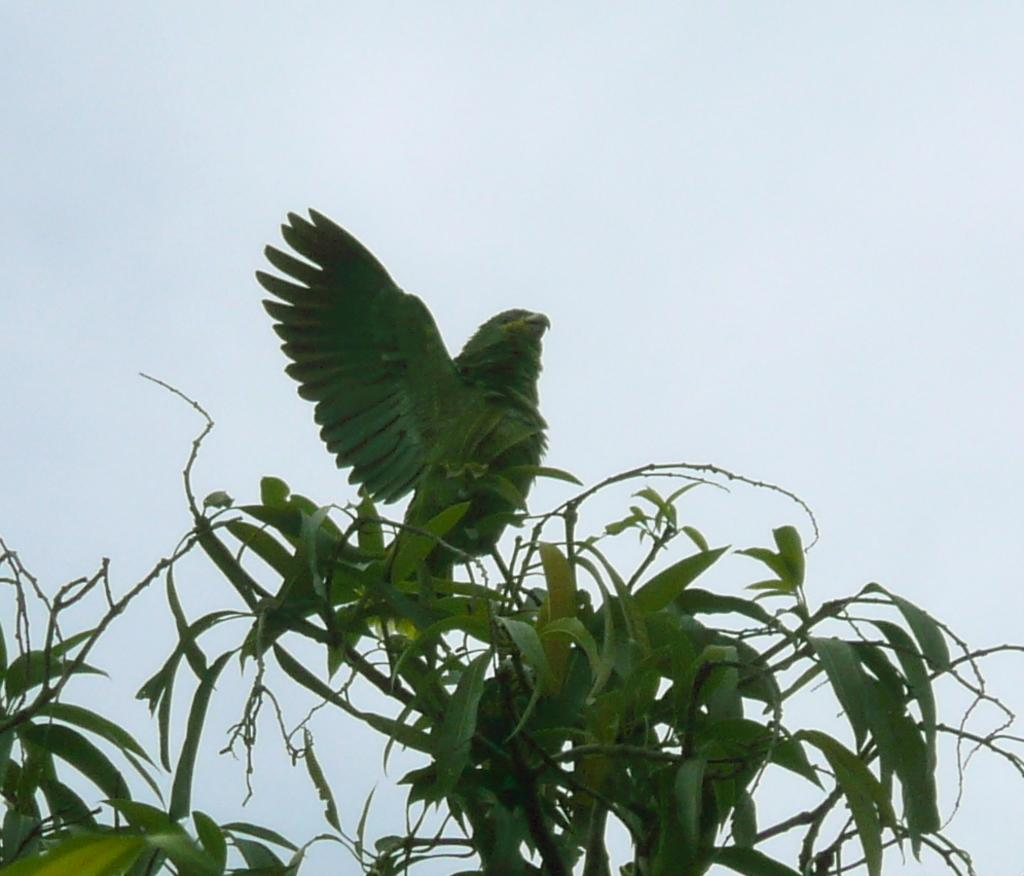What type of animal is in the image? There is a green color parrot in the image. Where is the parrot located? The parrot is on the branch of a plant. What can be seen in the sky in the image? The sky is clear and visible at the top of the image. What type of vegetation is present at the bottom of the image? Leaves are present at the bottom of the image. What suggestion does the parrot make to the viewer in the image? There is no suggestion made by the parrot in the image, as it is a still image and not capable of making suggestions. 